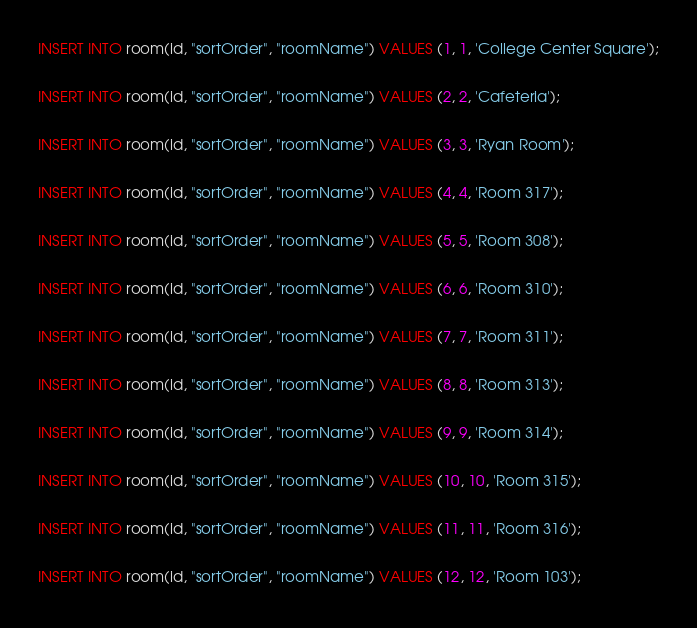<code> <loc_0><loc_0><loc_500><loc_500><_SQL_>INSERT INTO room(id, "sortOrder", "roomName") VALUES (1, 1, 'College Center Square');

INSERT INTO room(id, "sortOrder", "roomName") VALUES (2, 2, 'Cafeteria');

INSERT INTO room(id, "sortOrder", "roomName") VALUES (3, 3, 'Ryan Room');

INSERT INTO room(id, "sortOrder", "roomName") VALUES (4, 4, 'Room 317');

INSERT INTO room(id, "sortOrder", "roomName") VALUES (5, 5, 'Room 308');

INSERT INTO room(id, "sortOrder", "roomName") VALUES (6, 6, 'Room 310');

INSERT INTO room(id, "sortOrder", "roomName") VALUES (7, 7, 'Room 311');

INSERT INTO room(id, "sortOrder", "roomName") VALUES (8, 8, 'Room 313');

INSERT INTO room(id, "sortOrder", "roomName") VALUES (9, 9, 'Room 314');

INSERT INTO room(id, "sortOrder", "roomName") VALUES (10, 10, 'Room 315');

INSERT INTO room(id, "sortOrder", "roomName") VALUES (11, 11, 'Room 316');

INSERT INTO room(id, "sortOrder", "roomName") VALUES (12, 12, 'Room 103');</code> 